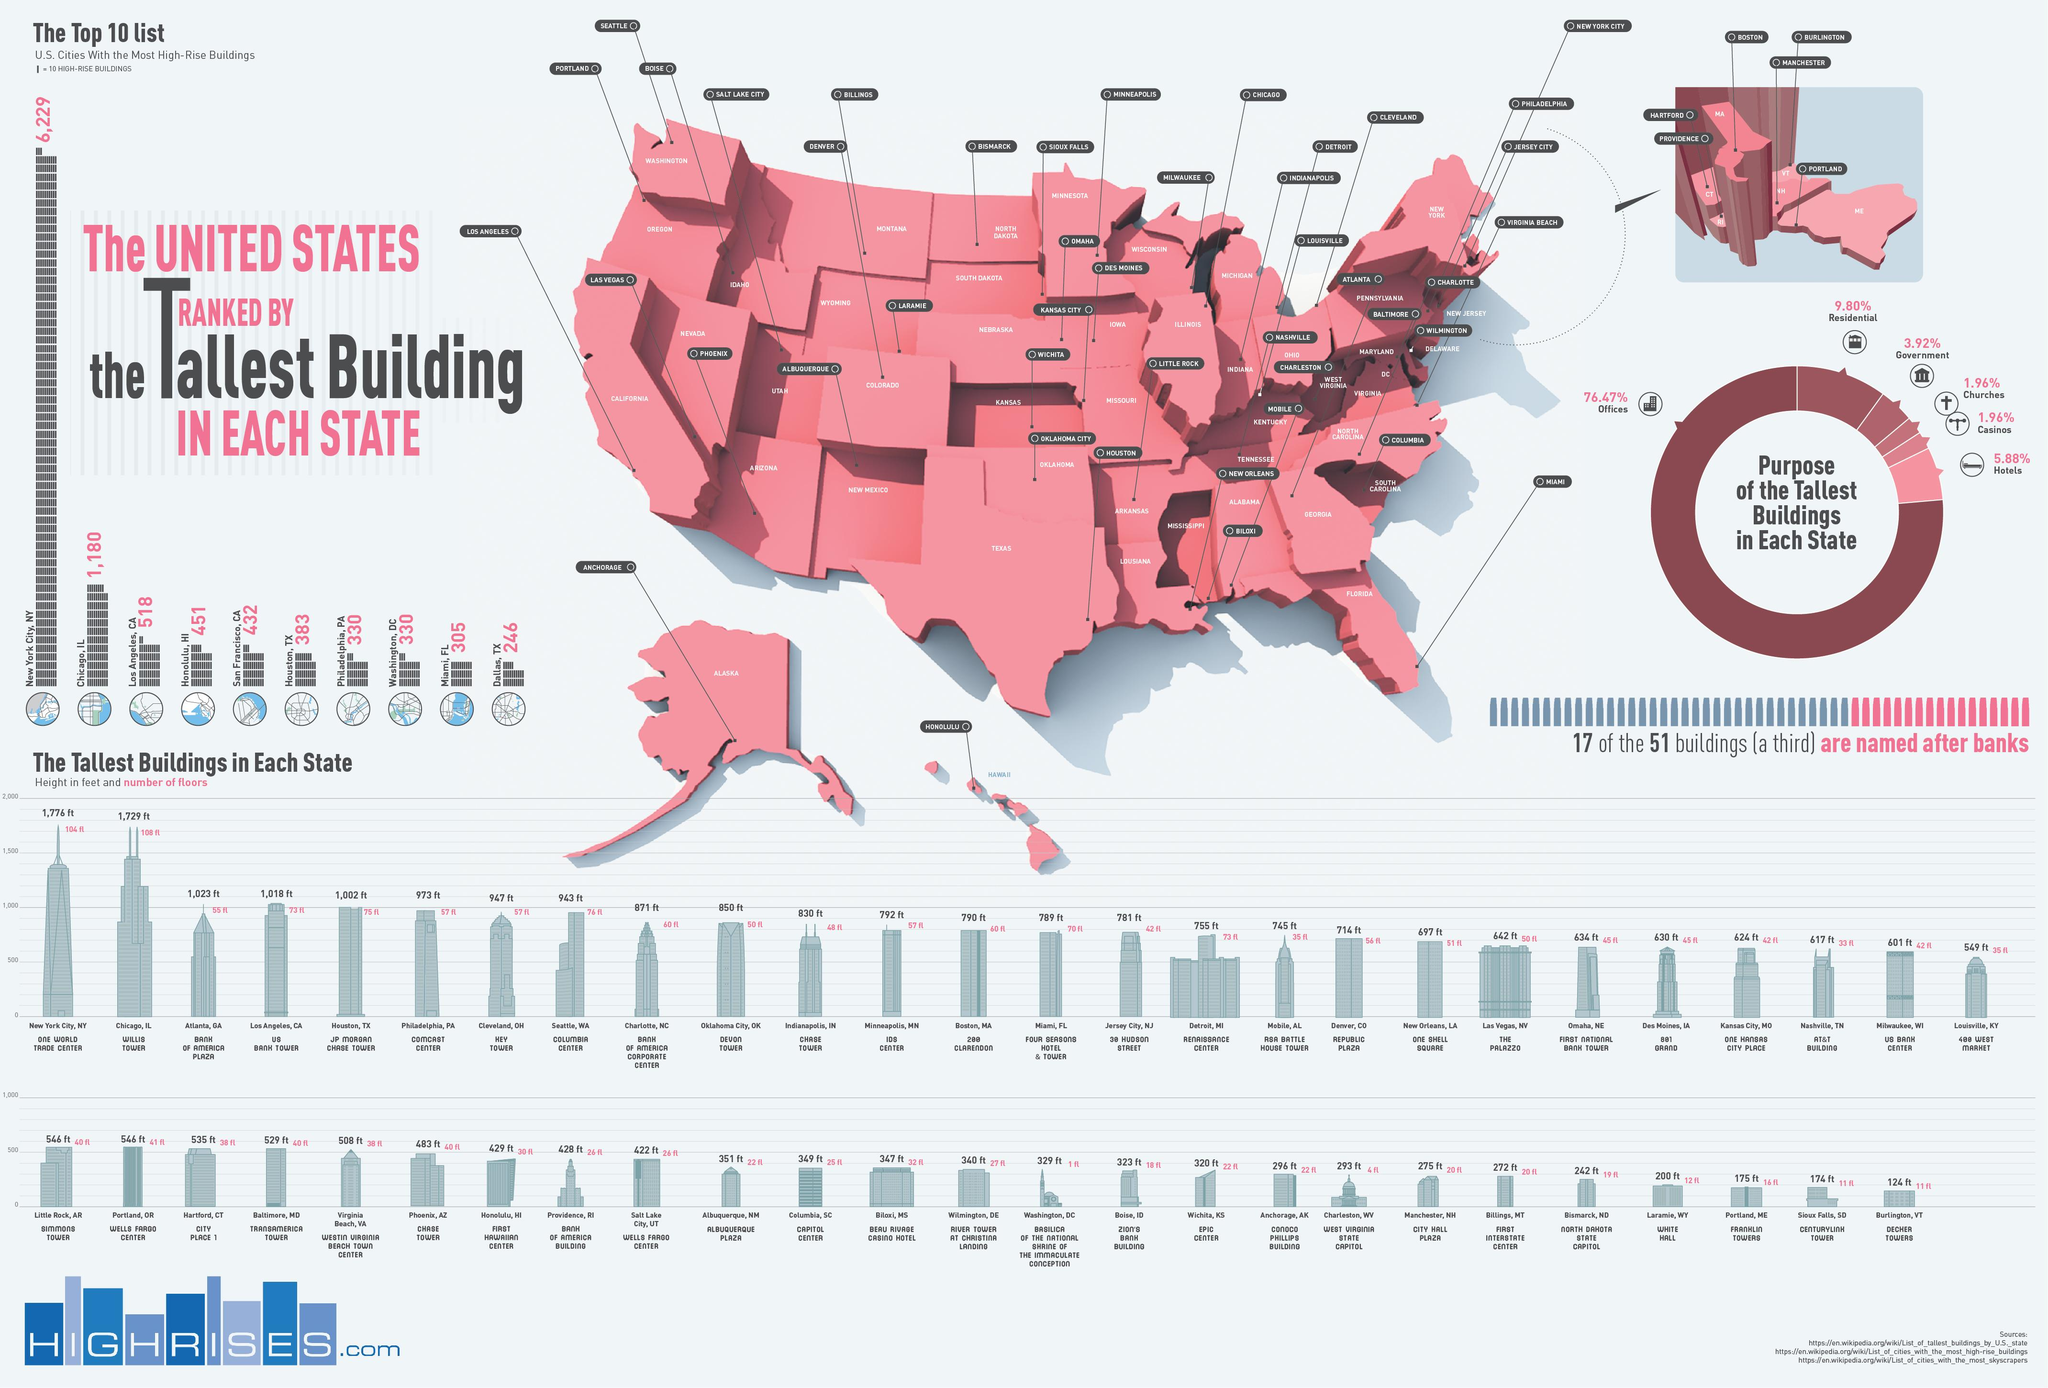Give some essential details in this illustration. The Republic Plaza building in Denver, Colorado has a height of 714 feet. One World Trade Center is the tallest building in New York City. The Willis Tower is the tallest building in Chicago, Illinois. In the city of Seattle, Washington, the Columbia Center is located. A majority, or 76.47%, of the tallest buildings in each state serve as offices. 